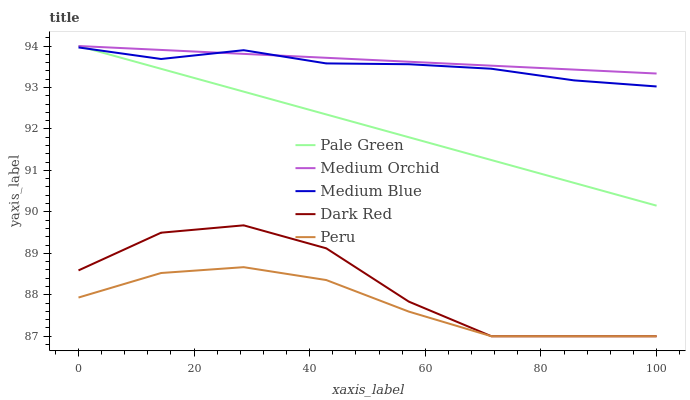Does Peru have the minimum area under the curve?
Answer yes or no. Yes. Does Medium Orchid have the maximum area under the curve?
Answer yes or no. Yes. Does Pale Green have the minimum area under the curve?
Answer yes or no. No. Does Pale Green have the maximum area under the curve?
Answer yes or no. No. Is Pale Green the smoothest?
Answer yes or no. Yes. Is Dark Red the roughest?
Answer yes or no. Yes. Is Medium Orchid the smoothest?
Answer yes or no. No. Is Medium Orchid the roughest?
Answer yes or no. No. Does Dark Red have the lowest value?
Answer yes or no. Yes. Does Pale Green have the lowest value?
Answer yes or no. No. Does Pale Green have the highest value?
Answer yes or no. Yes. Does Medium Blue have the highest value?
Answer yes or no. No. Is Peru less than Medium Orchid?
Answer yes or no. Yes. Is Medium Orchid greater than Peru?
Answer yes or no. Yes. Does Medium Orchid intersect Pale Green?
Answer yes or no. Yes. Is Medium Orchid less than Pale Green?
Answer yes or no. No. Is Medium Orchid greater than Pale Green?
Answer yes or no. No. Does Peru intersect Medium Orchid?
Answer yes or no. No. 